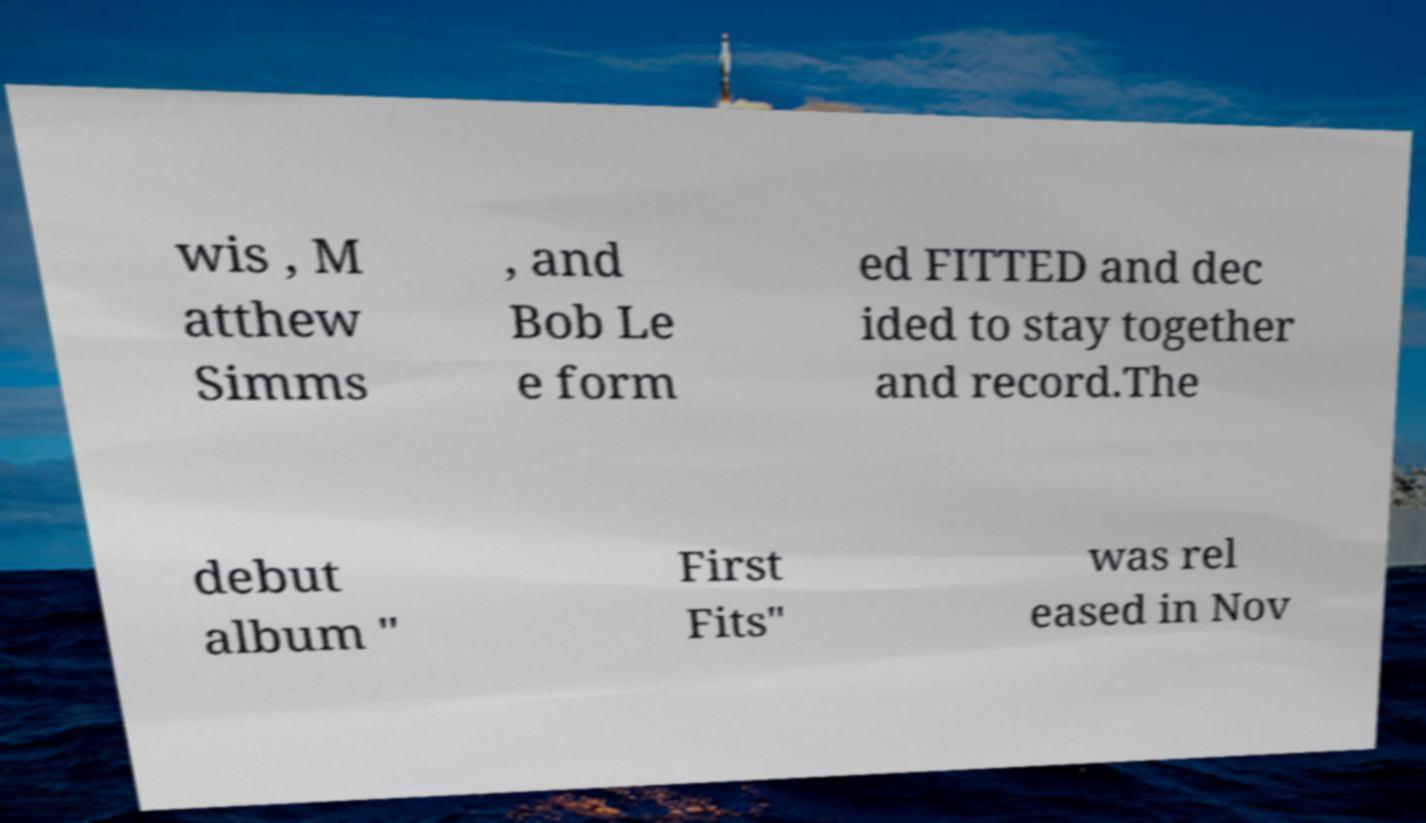I need the written content from this picture converted into text. Can you do that? wis , M atthew Simms , and Bob Le e form ed FITTED and dec ided to stay together and record.The debut album " First Fits" was rel eased in Nov 